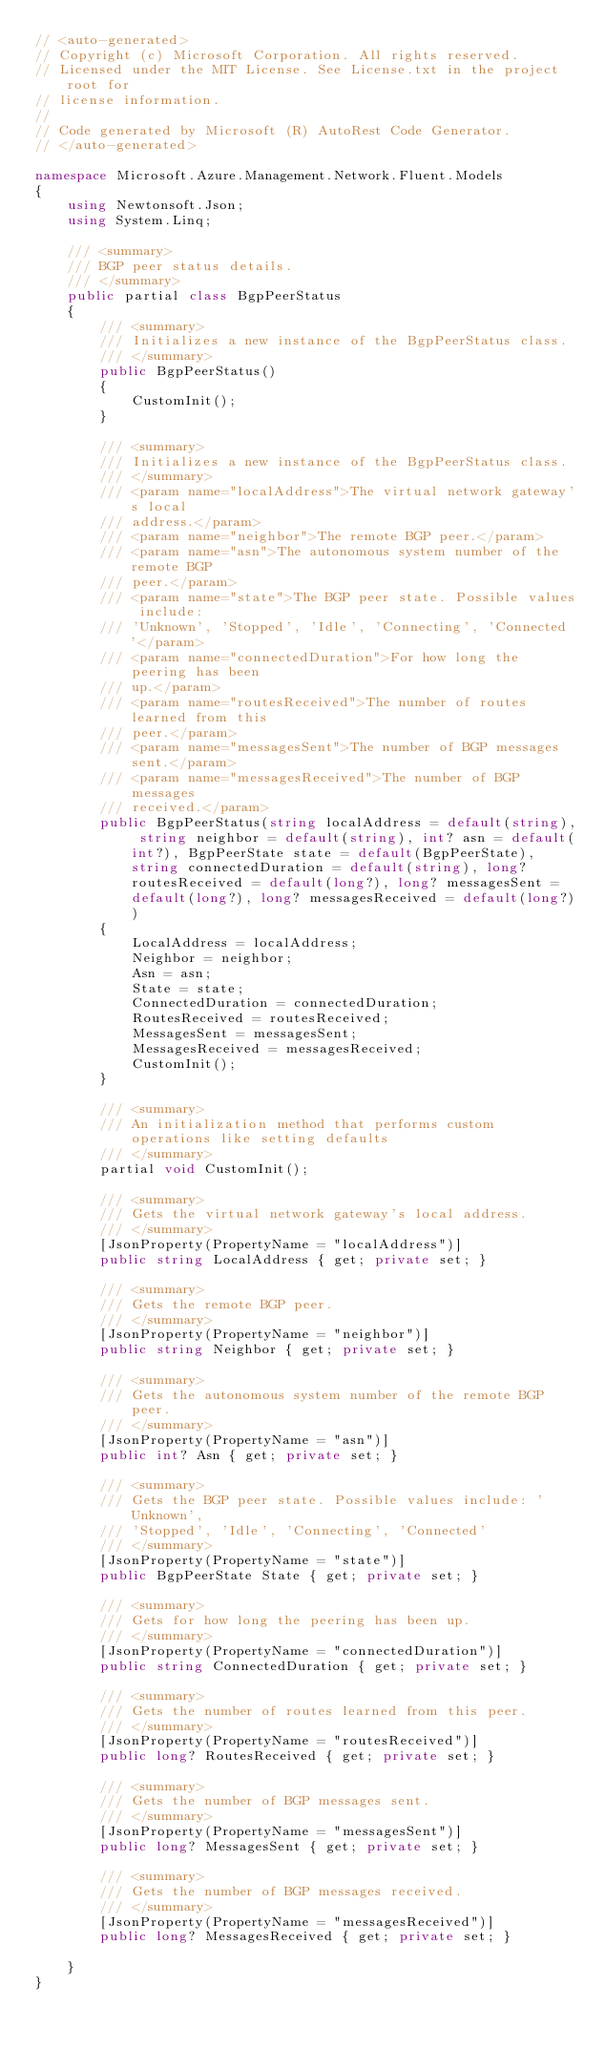<code> <loc_0><loc_0><loc_500><loc_500><_C#_>// <auto-generated>
// Copyright (c) Microsoft Corporation. All rights reserved.
// Licensed under the MIT License. See License.txt in the project root for
// license information.
//
// Code generated by Microsoft (R) AutoRest Code Generator.
// </auto-generated>

namespace Microsoft.Azure.Management.Network.Fluent.Models
{
    using Newtonsoft.Json;
    using System.Linq;

    /// <summary>
    /// BGP peer status details.
    /// </summary>
    public partial class BgpPeerStatus
    {
        /// <summary>
        /// Initializes a new instance of the BgpPeerStatus class.
        /// </summary>
        public BgpPeerStatus()
        {
            CustomInit();
        }

        /// <summary>
        /// Initializes a new instance of the BgpPeerStatus class.
        /// </summary>
        /// <param name="localAddress">The virtual network gateway's local
        /// address.</param>
        /// <param name="neighbor">The remote BGP peer.</param>
        /// <param name="asn">The autonomous system number of the remote BGP
        /// peer.</param>
        /// <param name="state">The BGP peer state. Possible values include:
        /// 'Unknown', 'Stopped', 'Idle', 'Connecting', 'Connected'</param>
        /// <param name="connectedDuration">For how long the peering has been
        /// up.</param>
        /// <param name="routesReceived">The number of routes learned from this
        /// peer.</param>
        /// <param name="messagesSent">The number of BGP messages sent.</param>
        /// <param name="messagesReceived">The number of BGP messages
        /// received.</param>
        public BgpPeerStatus(string localAddress = default(string), string neighbor = default(string), int? asn = default(int?), BgpPeerState state = default(BgpPeerState), string connectedDuration = default(string), long? routesReceived = default(long?), long? messagesSent = default(long?), long? messagesReceived = default(long?))
        {
            LocalAddress = localAddress;
            Neighbor = neighbor;
            Asn = asn;
            State = state;
            ConnectedDuration = connectedDuration;
            RoutesReceived = routesReceived;
            MessagesSent = messagesSent;
            MessagesReceived = messagesReceived;
            CustomInit();
        }

        /// <summary>
        /// An initialization method that performs custom operations like setting defaults
        /// </summary>
        partial void CustomInit();

        /// <summary>
        /// Gets the virtual network gateway's local address.
        /// </summary>
        [JsonProperty(PropertyName = "localAddress")]
        public string LocalAddress { get; private set; }

        /// <summary>
        /// Gets the remote BGP peer.
        /// </summary>
        [JsonProperty(PropertyName = "neighbor")]
        public string Neighbor { get; private set; }

        /// <summary>
        /// Gets the autonomous system number of the remote BGP peer.
        /// </summary>
        [JsonProperty(PropertyName = "asn")]
        public int? Asn { get; private set; }

        /// <summary>
        /// Gets the BGP peer state. Possible values include: 'Unknown',
        /// 'Stopped', 'Idle', 'Connecting', 'Connected'
        /// </summary>
        [JsonProperty(PropertyName = "state")]
        public BgpPeerState State { get; private set; }

        /// <summary>
        /// Gets for how long the peering has been up.
        /// </summary>
        [JsonProperty(PropertyName = "connectedDuration")]
        public string ConnectedDuration { get; private set; }

        /// <summary>
        /// Gets the number of routes learned from this peer.
        /// </summary>
        [JsonProperty(PropertyName = "routesReceived")]
        public long? RoutesReceived { get; private set; }

        /// <summary>
        /// Gets the number of BGP messages sent.
        /// </summary>
        [JsonProperty(PropertyName = "messagesSent")]
        public long? MessagesSent { get; private set; }

        /// <summary>
        /// Gets the number of BGP messages received.
        /// </summary>
        [JsonProperty(PropertyName = "messagesReceived")]
        public long? MessagesReceived { get; private set; }

    }
}
</code> 